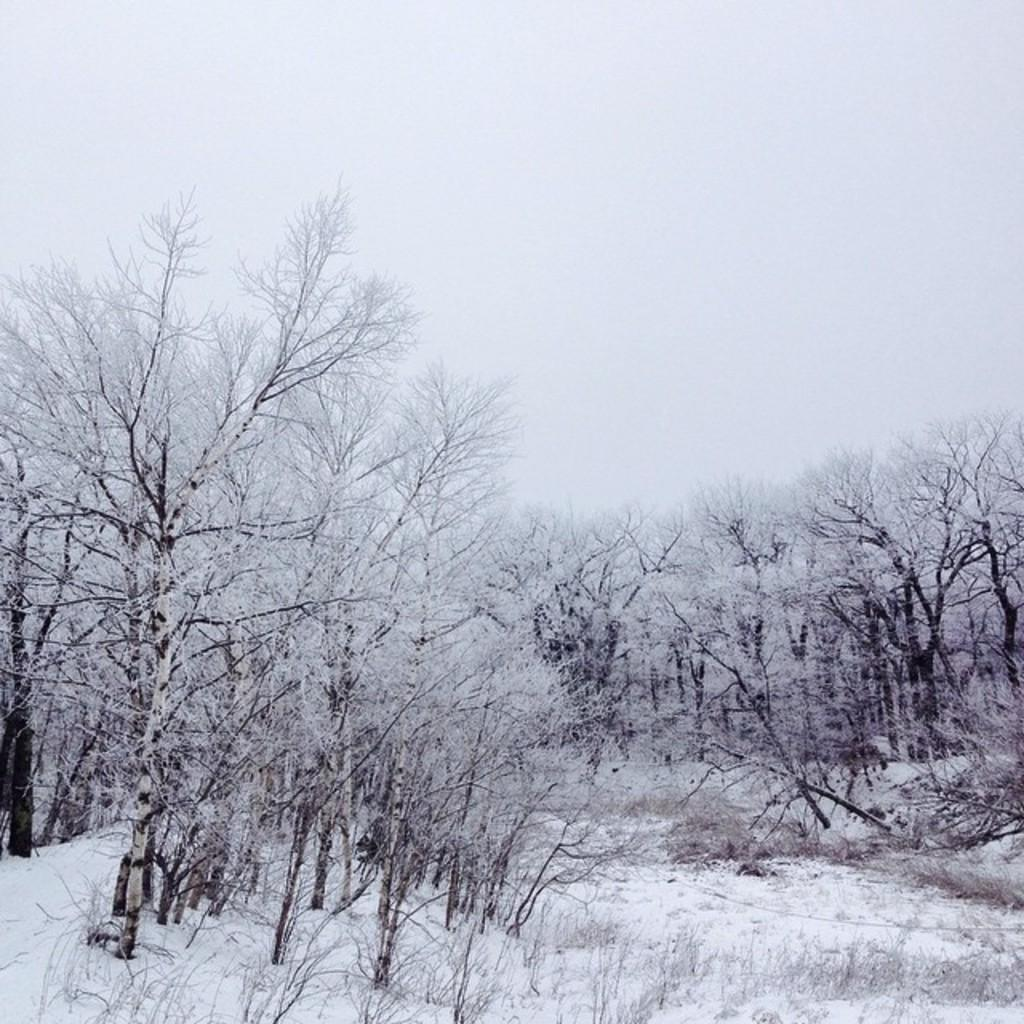What type of trees are visible in the image? There are bare trees in the image. What weather condition is depicted in the image? There is snow in the image. What is visible in the background of the image? The sky is visible in the background of the image. What type of ink can be seen dripping from the trees in the image? There is no ink present in the image; it features bare trees and snow. What type of furniture can be seen in the bedroom in the image? There is no bedroom present in the image; it features bare trees, snow, and the sky. 